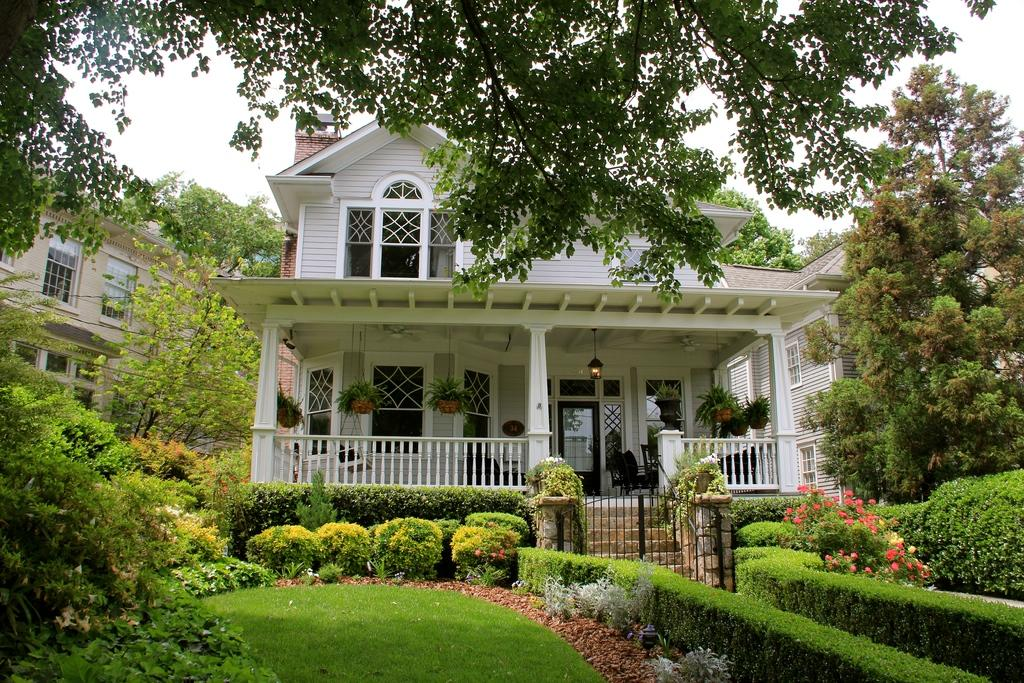What is located in the center of the image? There are buildings in the center of the image. What type of vegetation can be seen at the bottom of the image? Hedges and bushes are present at the bottom of the image. What architectural feature is present in the image? There is a gate in the image. What is a possible way to access the buildings in the image? There are stairs in the image, which could be used to access the buildings. What can be seen in the background of the image? Trees and the sky are visible in the background of the image. How does the desire for a trip manifest itself in the image? There is no mention of desire or a trip in the image; it features buildings, hedges, bushes, a gate, stairs, trees, and the sky. Can you touch the clouds in the image? The image is a two-dimensional representation, so it is not possible to touch the clouds or any other elements in the image. 